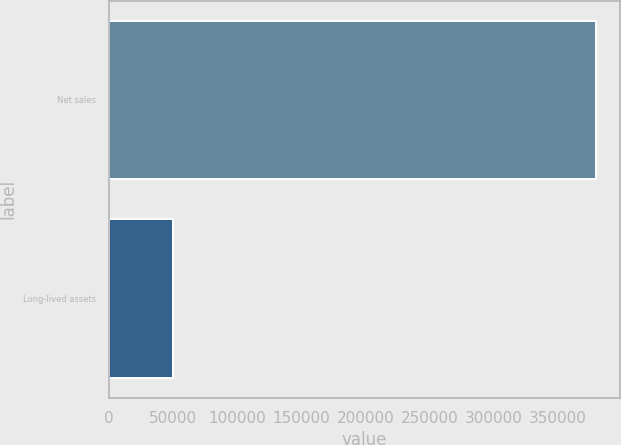Convert chart. <chart><loc_0><loc_0><loc_500><loc_500><bar_chart><fcel>Net sales<fcel>Long-lived assets<nl><fcel>379820<fcel>50077<nl></chart> 